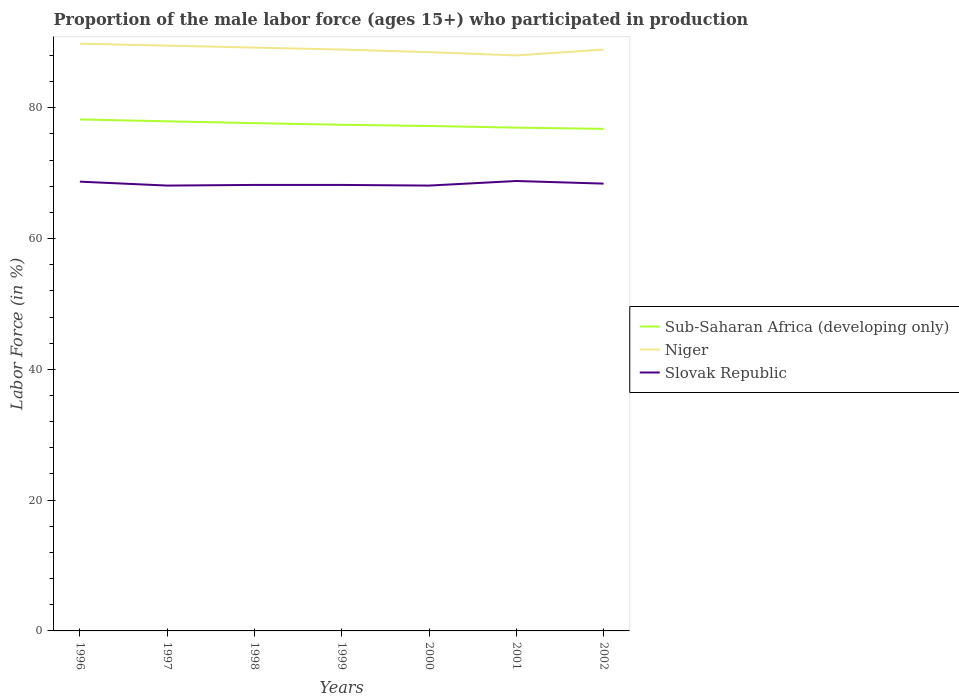How many different coloured lines are there?
Give a very brief answer. 3. Is the number of lines equal to the number of legend labels?
Offer a very short reply. Yes. In which year was the proportion of the male labor force who participated in production in Sub-Saharan Africa (developing only) maximum?
Offer a terse response. 2002. What is the total proportion of the male labor force who participated in production in Niger in the graph?
Offer a terse response. 0.4. What is the difference between the highest and the second highest proportion of the male labor force who participated in production in Niger?
Offer a terse response. 1.8. What is the difference between the highest and the lowest proportion of the male labor force who participated in production in Niger?
Your response must be concise. 3. Is the proportion of the male labor force who participated in production in Sub-Saharan Africa (developing only) strictly greater than the proportion of the male labor force who participated in production in Slovak Republic over the years?
Make the answer very short. No. How many lines are there?
Provide a short and direct response. 3. How many years are there in the graph?
Offer a terse response. 7. What is the difference between two consecutive major ticks on the Y-axis?
Keep it short and to the point. 20. Does the graph contain grids?
Your response must be concise. No. How many legend labels are there?
Your response must be concise. 3. What is the title of the graph?
Your answer should be compact. Proportion of the male labor force (ages 15+) who participated in production. What is the label or title of the Y-axis?
Offer a very short reply. Labor Force (in %). What is the Labor Force (in %) of Sub-Saharan Africa (developing only) in 1996?
Give a very brief answer. 78.21. What is the Labor Force (in %) in Niger in 1996?
Make the answer very short. 89.8. What is the Labor Force (in %) in Slovak Republic in 1996?
Your response must be concise. 68.7. What is the Labor Force (in %) in Sub-Saharan Africa (developing only) in 1997?
Ensure brevity in your answer.  77.92. What is the Labor Force (in %) of Niger in 1997?
Your answer should be compact. 89.5. What is the Labor Force (in %) in Slovak Republic in 1997?
Give a very brief answer. 68.1. What is the Labor Force (in %) of Sub-Saharan Africa (developing only) in 1998?
Keep it short and to the point. 77.65. What is the Labor Force (in %) in Niger in 1998?
Make the answer very short. 89.2. What is the Labor Force (in %) of Slovak Republic in 1998?
Ensure brevity in your answer.  68.2. What is the Labor Force (in %) of Sub-Saharan Africa (developing only) in 1999?
Your answer should be compact. 77.4. What is the Labor Force (in %) in Niger in 1999?
Give a very brief answer. 88.9. What is the Labor Force (in %) in Slovak Republic in 1999?
Make the answer very short. 68.2. What is the Labor Force (in %) in Sub-Saharan Africa (developing only) in 2000?
Offer a terse response. 77.21. What is the Labor Force (in %) in Niger in 2000?
Your answer should be compact. 88.5. What is the Labor Force (in %) in Slovak Republic in 2000?
Offer a terse response. 68.1. What is the Labor Force (in %) in Sub-Saharan Africa (developing only) in 2001?
Your response must be concise. 76.96. What is the Labor Force (in %) of Slovak Republic in 2001?
Offer a terse response. 68.8. What is the Labor Force (in %) of Sub-Saharan Africa (developing only) in 2002?
Your answer should be very brief. 76.77. What is the Labor Force (in %) of Niger in 2002?
Your answer should be compact. 88.9. What is the Labor Force (in %) of Slovak Republic in 2002?
Offer a very short reply. 68.4. Across all years, what is the maximum Labor Force (in %) of Sub-Saharan Africa (developing only)?
Offer a very short reply. 78.21. Across all years, what is the maximum Labor Force (in %) in Niger?
Give a very brief answer. 89.8. Across all years, what is the maximum Labor Force (in %) of Slovak Republic?
Keep it short and to the point. 68.8. Across all years, what is the minimum Labor Force (in %) of Sub-Saharan Africa (developing only)?
Ensure brevity in your answer.  76.77. Across all years, what is the minimum Labor Force (in %) of Niger?
Your answer should be very brief. 88. Across all years, what is the minimum Labor Force (in %) of Slovak Republic?
Make the answer very short. 68.1. What is the total Labor Force (in %) in Sub-Saharan Africa (developing only) in the graph?
Your response must be concise. 542.13. What is the total Labor Force (in %) in Niger in the graph?
Ensure brevity in your answer.  622.8. What is the total Labor Force (in %) in Slovak Republic in the graph?
Offer a terse response. 478.5. What is the difference between the Labor Force (in %) of Sub-Saharan Africa (developing only) in 1996 and that in 1997?
Your answer should be compact. 0.29. What is the difference between the Labor Force (in %) of Niger in 1996 and that in 1997?
Make the answer very short. 0.3. What is the difference between the Labor Force (in %) of Slovak Republic in 1996 and that in 1997?
Your response must be concise. 0.6. What is the difference between the Labor Force (in %) of Sub-Saharan Africa (developing only) in 1996 and that in 1998?
Offer a terse response. 0.57. What is the difference between the Labor Force (in %) in Niger in 1996 and that in 1998?
Give a very brief answer. 0.6. What is the difference between the Labor Force (in %) of Sub-Saharan Africa (developing only) in 1996 and that in 1999?
Your response must be concise. 0.81. What is the difference between the Labor Force (in %) of Sub-Saharan Africa (developing only) in 1996 and that in 2000?
Keep it short and to the point. 1. What is the difference between the Labor Force (in %) in Slovak Republic in 1996 and that in 2000?
Your response must be concise. 0.6. What is the difference between the Labor Force (in %) of Sub-Saharan Africa (developing only) in 1996 and that in 2001?
Offer a very short reply. 1.25. What is the difference between the Labor Force (in %) in Sub-Saharan Africa (developing only) in 1996 and that in 2002?
Your answer should be very brief. 1.44. What is the difference between the Labor Force (in %) of Slovak Republic in 1996 and that in 2002?
Offer a very short reply. 0.3. What is the difference between the Labor Force (in %) in Sub-Saharan Africa (developing only) in 1997 and that in 1998?
Provide a succinct answer. 0.28. What is the difference between the Labor Force (in %) of Niger in 1997 and that in 1998?
Offer a very short reply. 0.3. What is the difference between the Labor Force (in %) in Sub-Saharan Africa (developing only) in 1997 and that in 1999?
Provide a succinct answer. 0.52. What is the difference between the Labor Force (in %) in Niger in 1997 and that in 1999?
Your response must be concise. 0.6. What is the difference between the Labor Force (in %) of Slovak Republic in 1997 and that in 1999?
Ensure brevity in your answer.  -0.1. What is the difference between the Labor Force (in %) in Sub-Saharan Africa (developing only) in 1997 and that in 2000?
Your response must be concise. 0.71. What is the difference between the Labor Force (in %) in Niger in 1997 and that in 2000?
Keep it short and to the point. 1. What is the difference between the Labor Force (in %) in Slovak Republic in 1997 and that in 2000?
Make the answer very short. 0. What is the difference between the Labor Force (in %) of Sub-Saharan Africa (developing only) in 1997 and that in 2002?
Offer a terse response. 1.15. What is the difference between the Labor Force (in %) in Niger in 1997 and that in 2002?
Your response must be concise. 0.6. What is the difference between the Labor Force (in %) in Slovak Republic in 1997 and that in 2002?
Make the answer very short. -0.3. What is the difference between the Labor Force (in %) of Sub-Saharan Africa (developing only) in 1998 and that in 1999?
Ensure brevity in your answer.  0.25. What is the difference between the Labor Force (in %) of Niger in 1998 and that in 1999?
Your answer should be compact. 0.3. What is the difference between the Labor Force (in %) in Slovak Republic in 1998 and that in 1999?
Make the answer very short. 0. What is the difference between the Labor Force (in %) in Sub-Saharan Africa (developing only) in 1998 and that in 2000?
Your answer should be compact. 0.44. What is the difference between the Labor Force (in %) of Niger in 1998 and that in 2000?
Keep it short and to the point. 0.7. What is the difference between the Labor Force (in %) of Slovak Republic in 1998 and that in 2000?
Provide a succinct answer. 0.1. What is the difference between the Labor Force (in %) in Sub-Saharan Africa (developing only) in 1998 and that in 2001?
Keep it short and to the point. 0.69. What is the difference between the Labor Force (in %) of Slovak Republic in 1998 and that in 2001?
Your answer should be very brief. -0.6. What is the difference between the Labor Force (in %) of Sub-Saharan Africa (developing only) in 1998 and that in 2002?
Your answer should be very brief. 0.88. What is the difference between the Labor Force (in %) of Niger in 1998 and that in 2002?
Offer a terse response. 0.3. What is the difference between the Labor Force (in %) in Sub-Saharan Africa (developing only) in 1999 and that in 2000?
Provide a short and direct response. 0.19. What is the difference between the Labor Force (in %) in Sub-Saharan Africa (developing only) in 1999 and that in 2001?
Offer a terse response. 0.44. What is the difference between the Labor Force (in %) of Niger in 1999 and that in 2001?
Keep it short and to the point. 0.9. What is the difference between the Labor Force (in %) in Sub-Saharan Africa (developing only) in 1999 and that in 2002?
Provide a succinct answer. 0.63. What is the difference between the Labor Force (in %) in Niger in 1999 and that in 2002?
Ensure brevity in your answer.  0. What is the difference between the Labor Force (in %) of Sub-Saharan Africa (developing only) in 2000 and that in 2001?
Your answer should be compact. 0.25. What is the difference between the Labor Force (in %) of Slovak Republic in 2000 and that in 2001?
Provide a succinct answer. -0.7. What is the difference between the Labor Force (in %) in Sub-Saharan Africa (developing only) in 2000 and that in 2002?
Your response must be concise. 0.44. What is the difference between the Labor Force (in %) in Niger in 2000 and that in 2002?
Offer a very short reply. -0.4. What is the difference between the Labor Force (in %) in Slovak Republic in 2000 and that in 2002?
Offer a terse response. -0.3. What is the difference between the Labor Force (in %) of Sub-Saharan Africa (developing only) in 2001 and that in 2002?
Provide a short and direct response. 0.19. What is the difference between the Labor Force (in %) of Sub-Saharan Africa (developing only) in 1996 and the Labor Force (in %) of Niger in 1997?
Your answer should be very brief. -11.29. What is the difference between the Labor Force (in %) of Sub-Saharan Africa (developing only) in 1996 and the Labor Force (in %) of Slovak Republic in 1997?
Ensure brevity in your answer.  10.11. What is the difference between the Labor Force (in %) of Niger in 1996 and the Labor Force (in %) of Slovak Republic in 1997?
Your answer should be compact. 21.7. What is the difference between the Labor Force (in %) of Sub-Saharan Africa (developing only) in 1996 and the Labor Force (in %) of Niger in 1998?
Ensure brevity in your answer.  -10.99. What is the difference between the Labor Force (in %) of Sub-Saharan Africa (developing only) in 1996 and the Labor Force (in %) of Slovak Republic in 1998?
Give a very brief answer. 10.01. What is the difference between the Labor Force (in %) of Niger in 1996 and the Labor Force (in %) of Slovak Republic in 1998?
Provide a short and direct response. 21.6. What is the difference between the Labor Force (in %) in Sub-Saharan Africa (developing only) in 1996 and the Labor Force (in %) in Niger in 1999?
Your answer should be very brief. -10.69. What is the difference between the Labor Force (in %) of Sub-Saharan Africa (developing only) in 1996 and the Labor Force (in %) of Slovak Republic in 1999?
Offer a terse response. 10.01. What is the difference between the Labor Force (in %) of Niger in 1996 and the Labor Force (in %) of Slovak Republic in 1999?
Keep it short and to the point. 21.6. What is the difference between the Labor Force (in %) in Sub-Saharan Africa (developing only) in 1996 and the Labor Force (in %) in Niger in 2000?
Keep it short and to the point. -10.29. What is the difference between the Labor Force (in %) of Sub-Saharan Africa (developing only) in 1996 and the Labor Force (in %) of Slovak Republic in 2000?
Your response must be concise. 10.11. What is the difference between the Labor Force (in %) of Niger in 1996 and the Labor Force (in %) of Slovak Republic in 2000?
Give a very brief answer. 21.7. What is the difference between the Labor Force (in %) in Sub-Saharan Africa (developing only) in 1996 and the Labor Force (in %) in Niger in 2001?
Provide a succinct answer. -9.79. What is the difference between the Labor Force (in %) of Sub-Saharan Africa (developing only) in 1996 and the Labor Force (in %) of Slovak Republic in 2001?
Make the answer very short. 9.41. What is the difference between the Labor Force (in %) of Niger in 1996 and the Labor Force (in %) of Slovak Republic in 2001?
Keep it short and to the point. 21. What is the difference between the Labor Force (in %) in Sub-Saharan Africa (developing only) in 1996 and the Labor Force (in %) in Niger in 2002?
Offer a terse response. -10.69. What is the difference between the Labor Force (in %) in Sub-Saharan Africa (developing only) in 1996 and the Labor Force (in %) in Slovak Republic in 2002?
Your response must be concise. 9.81. What is the difference between the Labor Force (in %) of Niger in 1996 and the Labor Force (in %) of Slovak Republic in 2002?
Make the answer very short. 21.4. What is the difference between the Labor Force (in %) of Sub-Saharan Africa (developing only) in 1997 and the Labor Force (in %) of Niger in 1998?
Offer a very short reply. -11.28. What is the difference between the Labor Force (in %) of Sub-Saharan Africa (developing only) in 1997 and the Labor Force (in %) of Slovak Republic in 1998?
Offer a terse response. 9.72. What is the difference between the Labor Force (in %) of Niger in 1997 and the Labor Force (in %) of Slovak Republic in 1998?
Make the answer very short. 21.3. What is the difference between the Labor Force (in %) of Sub-Saharan Africa (developing only) in 1997 and the Labor Force (in %) of Niger in 1999?
Your answer should be very brief. -10.98. What is the difference between the Labor Force (in %) of Sub-Saharan Africa (developing only) in 1997 and the Labor Force (in %) of Slovak Republic in 1999?
Provide a short and direct response. 9.72. What is the difference between the Labor Force (in %) in Niger in 1997 and the Labor Force (in %) in Slovak Republic in 1999?
Your response must be concise. 21.3. What is the difference between the Labor Force (in %) in Sub-Saharan Africa (developing only) in 1997 and the Labor Force (in %) in Niger in 2000?
Make the answer very short. -10.58. What is the difference between the Labor Force (in %) of Sub-Saharan Africa (developing only) in 1997 and the Labor Force (in %) of Slovak Republic in 2000?
Make the answer very short. 9.82. What is the difference between the Labor Force (in %) in Niger in 1997 and the Labor Force (in %) in Slovak Republic in 2000?
Offer a terse response. 21.4. What is the difference between the Labor Force (in %) of Sub-Saharan Africa (developing only) in 1997 and the Labor Force (in %) of Niger in 2001?
Give a very brief answer. -10.08. What is the difference between the Labor Force (in %) of Sub-Saharan Africa (developing only) in 1997 and the Labor Force (in %) of Slovak Republic in 2001?
Your response must be concise. 9.12. What is the difference between the Labor Force (in %) in Niger in 1997 and the Labor Force (in %) in Slovak Republic in 2001?
Ensure brevity in your answer.  20.7. What is the difference between the Labor Force (in %) of Sub-Saharan Africa (developing only) in 1997 and the Labor Force (in %) of Niger in 2002?
Offer a terse response. -10.98. What is the difference between the Labor Force (in %) in Sub-Saharan Africa (developing only) in 1997 and the Labor Force (in %) in Slovak Republic in 2002?
Provide a short and direct response. 9.52. What is the difference between the Labor Force (in %) in Niger in 1997 and the Labor Force (in %) in Slovak Republic in 2002?
Give a very brief answer. 21.1. What is the difference between the Labor Force (in %) in Sub-Saharan Africa (developing only) in 1998 and the Labor Force (in %) in Niger in 1999?
Your response must be concise. -11.25. What is the difference between the Labor Force (in %) in Sub-Saharan Africa (developing only) in 1998 and the Labor Force (in %) in Slovak Republic in 1999?
Your answer should be very brief. 9.45. What is the difference between the Labor Force (in %) in Sub-Saharan Africa (developing only) in 1998 and the Labor Force (in %) in Niger in 2000?
Provide a succinct answer. -10.85. What is the difference between the Labor Force (in %) of Sub-Saharan Africa (developing only) in 1998 and the Labor Force (in %) of Slovak Republic in 2000?
Give a very brief answer. 9.55. What is the difference between the Labor Force (in %) in Niger in 1998 and the Labor Force (in %) in Slovak Republic in 2000?
Provide a short and direct response. 21.1. What is the difference between the Labor Force (in %) in Sub-Saharan Africa (developing only) in 1998 and the Labor Force (in %) in Niger in 2001?
Offer a terse response. -10.35. What is the difference between the Labor Force (in %) in Sub-Saharan Africa (developing only) in 1998 and the Labor Force (in %) in Slovak Republic in 2001?
Your response must be concise. 8.85. What is the difference between the Labor Force (in %) of Niger in 1998 and the Labor Force (in %) of Slovak Republic in 2001?
Ensure brevity in your answer.  20.4. What is the difference between the Labor Force (in %) of Sub-Saharan Africa (developing only) in 1998 and the Labor Force (in %) of Niger in 2002?
Keep it short and to the point. -11.25. What is the difference between the Labor Force (in %) in Sub-Saharan Africa (developing only) in 1998 and the Labor Force (in %) in Slovak Republic in 2002?
Your answer should be compact. 9.25. What is the difference between the Labor Force (in %) of Niger in 1998 and the Labor Force (in %) of Slovak Republic in 2002?
Provide a short and direct response. 20.8. What is the difference between the Labor Force (in %) of Sub-Saharan Africa (developing only) in 1999 and the Labor Force (in %) of Niger in 2000?
Your answer should be compact. -11.1. What is the difference between the Labor Force (in %) in Sub-Saharan Africa (developing only) in 1999 and the Labor Force (in %) in Slovak Republic in 2000?
Provide a short and direct response. 9.3. What is the difference between the Labor Force (in %) of Niger in 1999 and the Labor Force (in %) of Slovak Republic in 2000?
Offer a terse response. 20.8. What is the difference between the Labor Force (in %) in Sub-Saharan Africa (developing only) in 1999 and the Labor Force (in %) in Niger in 2001?
Provide a short and direct response. -10.6. What is the difference between the Labor Force (in %) of Sub-Saharan Africa (developing only) in 1999 and the Labor Force (in %) of Slovak Republic in 2001?
Offer a very short reply. 8.6. What is the difference between the Labor Force (in %) of Niger in 1999 and the Labor Force (in %) of Slovak Republic in 2001?
Provide a short and direct response. 20.1. What is the difference between the Labor Force (in %) in Sub-Saharan Africa (developing only) in 1999 and the Labor Force (in %) in Niger in 2002?
Make the answer very short. -11.5. What is the difference between the Labor Force (in %) of Sub-Saharan Africa (developing only) in 1999 and the Labor Force (in %) of Slovak Republic in 2002?
Offer a terse response. 9. What is the difference between the Labor Force (in %) of Niger in 1999 and the Labor Force (in %) of Slovak Republic in 2002?
Offer a terse response. 20.5. What is the difference between the Labor Force (in %) of Sub-Saharan Africa (developing only) in 2000 and the Labor Force (in %) of Niger in 2001?
Keep it short and to the point. -10.79. What is the difference between the Labor Force (in %) of Sub-Saharan Africa (developing only) in 2000 and the Labor Force (in %) of Slovak Republic in 2001?
Offer a very short reply. 8.41. What is the difference between the Labor Force (in %) in Niger in 2000 and the Labor Force (in %) in Slovak Republic in 2001?
Make the answer very short. 19.7. What is the difference between the Labor Force (in %) in Sub-Saharan Africa (developing only) in 2000 and the Labor Force (in %) in Niger in 2002?
Provide a succinct answer. -11.69. What is the difference between the Labor Force (in %) of Sub-Saharan Africa (developing only) in 2000 and the Labor Force (in %) of Slovak Republic in 2002?
Offer a terse response. 8.81. What is the difference between the Labor Force (in %) in Niger in 2000 and the Labor Force (in %) in Slovak Republic in 2002?
Provide a short and direct response. 20.1. What is the difference between the Labor Force (in %) of Sub-Saharan Africa (developing only) in 2001 and the Labor Force (in %) of Niger in 2002?
Provide a succinct answer. -11.94. What is the difference between the Labor Force (in %) of Sub-Saharan Africa (developing only) in 2001 and the Labor Force (in %) of Slovak Republic in 2002?
Offer a terse response. 8.56. What is the difference between the Labor Force (in %) in Niger in 2001 and the Labor Force (in %) in Slovak Republic in 2002?
Provide a succinct answer. 19.6. What is the average Labor Force (in %) of Sub-Saharan Africa (developing only) per year?
Give a very brief answer. 77.45. What is the average Labor Force (in %) in Niger per year?
Keep it short and to the point. 88.97. What is the average Labor Force (in %) of Slovak Republic per year?
Your answer should be very brief. 68.36. In the year 1996, what is the difference between the Labor Force (in %) of Sub-Saharan Africa (developing only) and Labor Force (in %) of Niger?
Provide a succinct answer. -11.59. In the year 1996, what is the difference between the Labor Force (in %) of Sub-Saharan Africa (developing only) and Labor Force (in %) of Slovak Republic?
Offer a terse response. 9.51. In the year 1996, what is the difference between the Labor Force (in %) of Niger and Labor Force (in %) of Slovak Republic?
Make the answer very short. 21.1. In the year 1997, what is the difference between the Labor Force (in %) of Sub-Saharan Africa (developing only) and Labor Force (in %) of Niger?
Ensure brevity in your answer.  -11.58. In the year 1997, what is the difference between the Labor Force (in %) in Sub-Saharan Africa (developing only) and Labor Force (in %) in Slovak Republic?
Your answer should be compact. 9.82. In the year 1997, what is the difference between the Labor Force (in %) of Niger and Labor Force (in %) of Slovak Republic?
Give a very brief answer. 21.4. In the year 1998, what is the difference between the Labor Force (in %) of Sub-Saharan Africa (developing only) and Labor Force (in %) of Niger?
Your answer should be compact. -11.55. In the year 1998, what is the difference between the Labor Force (in %) in Sub-Saharan Africa (developing only) and Labor Force (in %) in Slovak Republic?
Your answer should be compact. 9.45. In the year 1999, what is the difference between the Labor Force (in %) of Sub-Saharan Africa (developing only) and Labor Force (in %) of Niger?
Offer a very short reply. -11.5. In the year 1999, what is the difference between the Labor Force (in %) of Sub-Saharan Africa (developing only) and Labor Force (in %) of Slovak Republic?
Give a very brief answer. 9.2. In the year 1999, what is the difference between the Labor Force (in %) in Niger and Labor Force (in %) in Slovak Republic?
Your response must be concise. 20.7. In the year 2000, what is the difference between the Labor Force (in %) in Sub-Saharan Africa (developing only) and Labor Force (in %) in Niger?
Ensure brevity in your answer.  -11.29. In the year 2000, what is the difference between the Labor Force (in %) in Sub-Saharan Africa (developing only) and Labor Force (in %) in Slovak Republic?
Your answer should be compact. 9.11. In the year 2000, what is the difference between the Labor Force (in %) in Niger and Labor Force (in %) in Slovak Republic?
Your response must be concise. 20.4. In the year 2001, what is the difference between the Labor Force (in %) of Sub-Saharan Africa (developing only) and Labor Force (in %) of Niger?
Provide a short and direct response. -11.04. In the year 2001, what is the difference between the Labor Force (in %) of Sub-Saharan Africa (developing only) and Labor Force (in %) of Slovak Republic?
Keep it short and to the point. 8.16. In the year 2002, what is the difference between the Labor Force (in %) of Sub-Saharan Africa (developing only) and Labor Force (in %) of Niger?
Provide a short and direct response. -12.13. In the year 2002, what is the difference between the Labor Force (in %) in Sub-Saharan Africa (developing only) and Labor Force (in %) in Slovak Republic?
Offer a terse response. 8.37. What is the ratio of the Labor Force (in %) of Sub-Saharan Africa (developing only) in 1996 to that in 1997?
Keep it short and to the point. 1. What is the ratio of the Labor Force (in %) of Niger in 1996 to that in 1997?
Your answer should be compact. 1. What is the ratio of the Labor Force (in %) of Slovak Republic in 1996 to that in 1997?
Provide a short and direct response. 1.01. What is the ratio of the Labor Force (in %) of Sub-Saharan Africa (developing only) in 1996 to that in 1998?
Keep it short and to the point. 1.01. What is the ratio of the Labor Force (in %) of Niger in 1996 to that in 1998?
Your answer should be compact. 1.01. What is the ratio of the Labor Force (in %) of Slovak Republic in 1996 to that in 1998?
Provide a succinct answer. 1.01. What is the ratio of the Labor Force (in %) in Sub-Saharan Africa (developing only) in 1996 to that in 1999?
Offer a very short reply. 1.01. What is the ratio of the Labor Force (in %) in Slovak Republic in 1996 to that in 1999?
Offer a terse response. 1.01. What is the ratio of the Labor Force (in %) in Niger in 1996 to that in 2000?
Make the answer very short. 1.01. What is the ratio of the Labor Force (in %) in Slovak Republic in 1996 to that in 2000?
Offer a very short reply. 1.01. What is the ratio of the Labor Force (in %) in Sub-Saharan Africa (developing only) in 1996 to that in 2001?
Keep it short and to the point. 1.02. What is the ratio of the Labor Force (in %) of Niger in 1996 to that in 2001?
Ensure brevity in your answer.  1.02. What is the ratio of the Labor Force (in %) in Sub-Saharan Africa (developing only) in 1996 to that in 2002?
Ensure brevity in your answer.  1.02. What is the ratio of the Labor Force (in %) in Sub-Saharan Africa (developing only) in 1997 to that in 1998?
Offer a terse response. 1. What is the ratio of the Labor Force (in %) in Niger in 1997 to that in 1998?
Offer a terse response. 1. What is the ratio of the Labor Force (in %) in Sub-Saharan Africa (developing only) in 1997 to that in 1999?
Provide a short and direct response. 1.01. What is the ratio of the Labor Force (in %) of Sub-Saharan Africa (developing only) in 1997 to that in 2000?
Offer a very short reply. 1.01. What is the ratio of the Labor Force (in %) in Niger in 1997 to that in 2000?
Provide a succinct answer. 1.01. What is the ratio of the Labor Force (in %) of Sub-Saharan Africa (developing only) in 1997 to that in 2001?
Offer a terse response. 1.01. What is the ratio of the Labor Force (in %) of Slovak Republic in 1997 to that in 2001?
Provide a succinct answer. 0.99. What is the ratio of the Labor Force (in %) of Sub-Saharan Africa (developing only) in 1997 to that in 2002?
Provide a succinct answer. 1.01. What is the ratio of the Labor Force (in %) of Niger in 1997 to that in 2002?
Provide a succinct answer. 1.01. What is the ratio of the Labor Force (in %) of Slovak Republic in 1997 to that in 2002?
Offer a very short reply. 1. What is the ratio of the Labor Force (in %) of Sub-Saharan Africa (developing only) in 1998 to that in 1999?
Provide a succinct answer. 1. What is the ratio of the Labor Force (in %) in Niger in 1998 to that in 2000?
Provide a succinct answer. 1.01. What is the ratio of the Labor Force (in %) of Slovak Republic in 1998 to that in 2000?
Ensure brevity in your answer.  1. What is the ratio of the Labor Force (in %) of Sub-Saharan Africa (developing only) in 1998 to that in 2001?
Give a very brief answer. 1.01. What is the ratio of the Labor Force (in %) in Niger in 1998 to that in 2001?
Your answer should be very brief. 1.01. What is the ratio of the Labor Force (in %) of Slovak Republic in 1998 to that in 2001?
Your answer should be compact. 0.99. What is the ratio of the Labor Force (in %) in Sub-Saharan Africa (developing only) in 1998 to that in 2002?
Offer a very short reply. 1.01. What is the ratio of the Labor Force (in %) in Sub-Saharan Africa (developing only) in 1999 to that in 2000?
Your answer should be compact. 1. What is the ratio of the Labor Force (in %) in Niger in 1999 to that in 2000?
Make the answer very short. 1. What is the ratio of the Labor Force (in %) in Niger in 1999 to that in 2001?
Provide a short and direct response. 1.01. What is the ratio of the Labor Force (in %) of Slovak Republic in 1999 to that in 2001?
Provide a short and direct response. 0.99. What is the ratio of the Labor Force (in %) of Sub-Saharan Africa (developing only) in 1999 to that in 2002?
Give a very brief answer. 1.01. What is the ratio of the Labor Force (in %) of Slovak Republic in 1999 to that in 2002?
Make the answer very short. 1. What is the ratio of the Labor Force (in %) in Niger in 2000 to that in 2001?
Give a very brief answer. 1.01. What is the ratio of the Labor Force (in %) of Sub-Saharan Africa (developing only) in 2000 to that in 2002?
Provide a succinct answer. 1.01. What is the ratio of the Labor Force (in %) of Slovak Republic in 2000 to that in 2002?
Ensure brevity in your answer.  1. What is the difference between the highest and the second highest Labor Force (in %) in Sub-Saharan Africa (developing only)?
Provide a short and direct response. 0.29. What is the difference between the highest and the second highest Labor Force (in %) in Niger?
Your response must be concise. 0.3. What is the difference between the highest and the lowest Labor Force (in %) of Sub-Saharan Africa (developing only)?
Provide a succinct answer. 1.44. What is the difference between the highest and the lowest Labor Force (in %) of Slovak Republic?
Your answer should be compact. 0.7. 